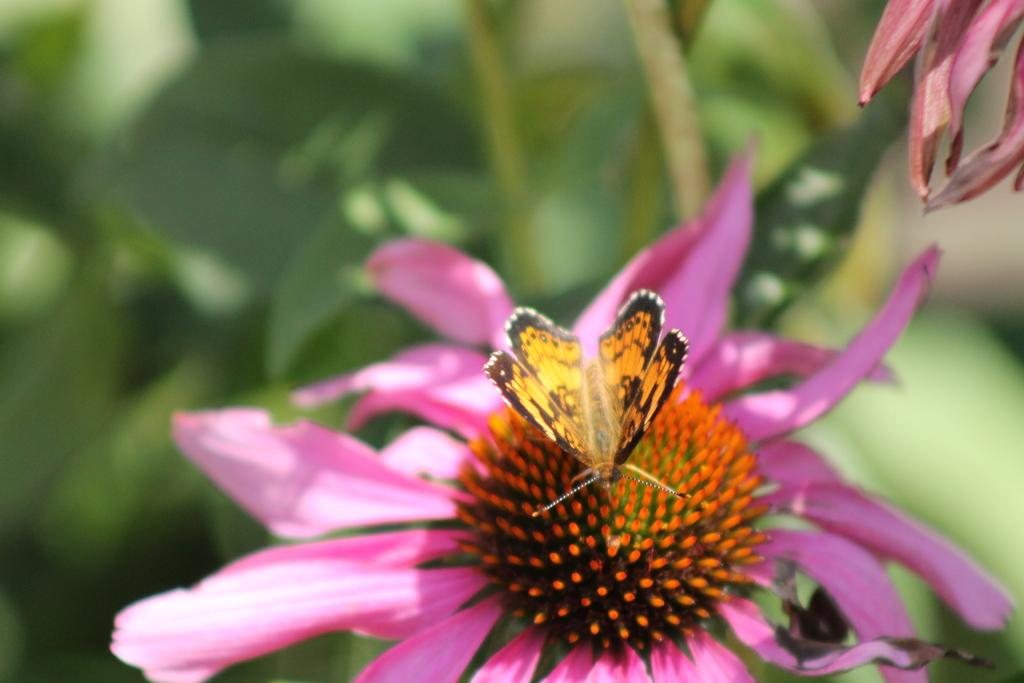What is the main subject of the image? There is a butterfly in the image. Where is the butterfly located? The butterfly is on a flower. What can be seen in the background of the image? There are leaves and petals in the background of the image. What is the name of the place where the butterfly's team is located? There is no mention of a place or team in the image, as it only features a butterfly on a flower with leaves and petals in the background. 